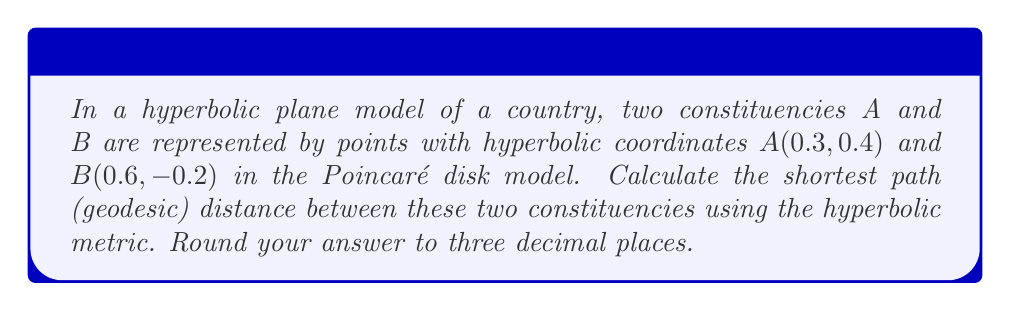Can you answer this question? To solve this problem, we'll follow these steps:

1) In the Poincaré disk model of hyperbolic geometry, the distance $d$ between two points $(x_1, y_1)$ and $(x_2, y_2)$ is given by the formula:

   $$d = \text{arcosh}\left(1 + \frac{2(x_1-x_2)^2 + 2(y_1-y_2)^2}{(1-x_1^2-y_1^2)(1-x_2^2-y_2^2)}\right)$$

   Where arcosh is the inverse hyperbolic cosine function.

2) We have:
   $A(x_1, y_1) = (0.3, 0.4)$
   $B(x_2, y_2) = (0.6, -0.2)$

3) Let's calculate the components:
   $(x_1-x_2)^2 = (0.3-0.6)^2 = (-0.3)^2 = 0.09$
   $(y_1-y_2)^2 = (0.4-(-0.2))^2 = 0.6^2 = 0.36$

   $1-x_1^2-y_1^2 = 1-0.3^2-0.4^2 = 1-0.09-0.16 = 0.75$
   $1-x_2^2-y_2^2 = 1-0.6^2-(-0.2)^2 = 1-0.36-0.04 = 0.60$

4) Now, let's plug these into our distance formula:

   $$d = \text{arcosh}\left(1 + \frac{2(0.09) + 2(0.36)}{(0.75)(0.60)}\right)$$

5) Simplify:
   $$d = \text{arcosh}\left(1 + \frac{0.18 + 0.72}{0.45}\right) = \text{arcosh}\left(1 + 2\right) = \text{arcosh}(3)$$

6) Calculate:
   $$d \approx 1.762747174039086$$

7) Rounding to three decimal places:
   $$d \approx 1.763$$
Answer: 1.763 